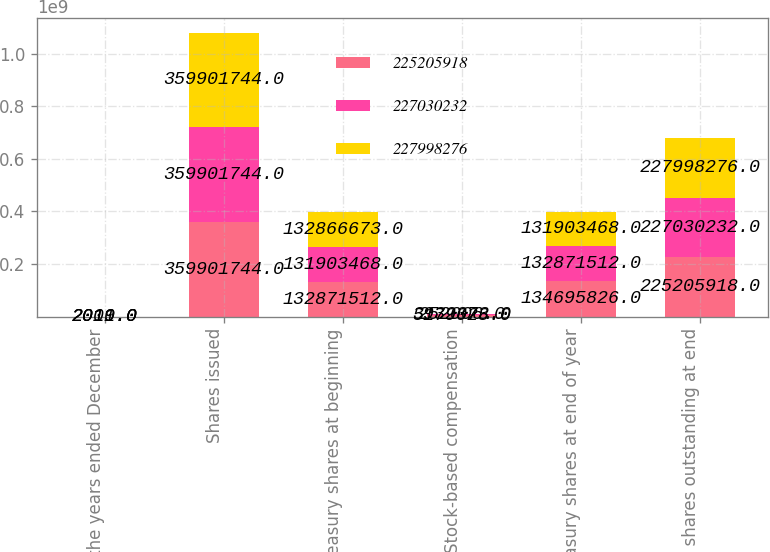Convert chart. <chart><loc_0><loc_0><loc_500><loc_500><stacked_bar_chart><ecel><fcel>For the years ended December<fcel>Shares issued<fcel>Treasury shares at beginning<fcel>Stock-based compensation<fcel>Treasury shares at end of year<fcel>Net shares outstanding at end<nl><fcel>2.25206e+08<fcel>2011<fcel>3.59902e+08<fcel>1.32872e+08<fcel>5.17903e+06<fcel>1.34696e+08<fcel>2.25206e+08<nl><fcel>2.2703e+08<fcel>2010<fcel>3.59902e+08<fcel>1.31903e+08<fcel>3.93237e+06<fcel>1.32872e+08<fcel>2.2703e+08<nl><fcel>2.27998e+08<fcel>2009<fcel>3.59902e+08<fcel>1.32867e+08<fcel>252006<fcel>1.31903e+08<fcel>2.27998e+08<nl></chart> 